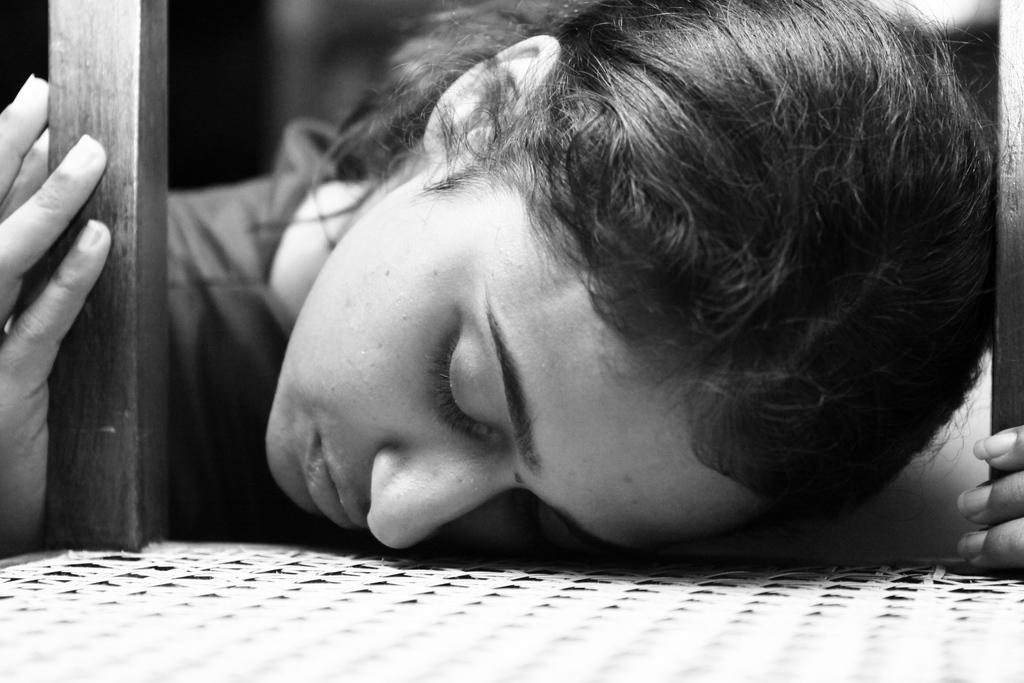Who is the main subject in the image? There is a woman in the image. What is the woman doing in the image? The woman is sleeping. Where is the woman located in the image? The woman is on a chair. Can you describe the background of the image? The background of the image is blurred. What type of club does the woman belong to in the image? There is no club mentioned or depicted in the image. 